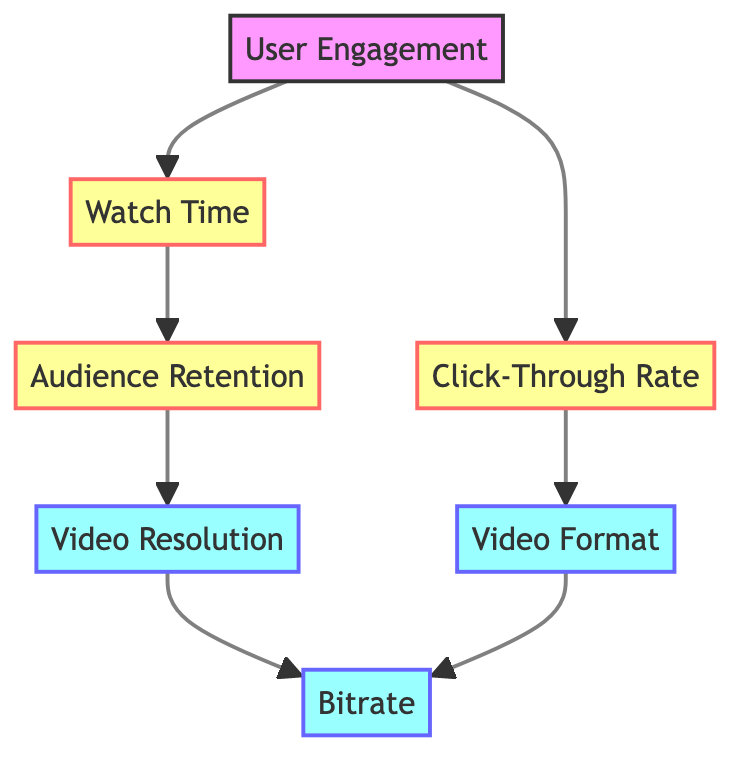What is the total number of nodes in the diagram? There are seven distinct nodes presented in the diagram: User Engagement, Watch Time, Click-Through Rate, Audience Retention, Video Resolution, Bitrate, and Video Format.
Answer: 7 What does the edge from User Engagement to Watch Time represent? This edge represents the direct influence or relationship between User Engagement and Watch Time, indicating that higher user engagement typically leads to increased watch time of videos.
Answer: Influence Which node is influenced by Audience Retention? Audience Retention influences Video Resolution, as indicated by the directed edge in the diagram that points from Audience Retention to Video Resolution.
Answer: Video Resolution What are the two nodes that directly connect to Bitrate? The two nodes that connect directly to Bitrate are Video Resolution and Video Format, as shown by the edges pointing to Bitrate from these nodes.
Answer: Video Resolution, Video Format How many edges are there in the diagram? The diagram contains six edges, representing the relationships between the nodes that illustrate how they influence one another.
Answer: 6 Which metric is influenced by both User Engagement and Watch Time? The metric influenced by both User Engagement and Watch Time is Audience Retention, as it is connected by directed edges from both metrics.
Answer: Audience Retention What is the relationship between Click-Through Rate and Video Format? Click-Through Rate directly influences Video Format, as shown by the arrow pointing from Click-Through Rate to Video Format, reflecting that a higher Click-Through Rate may lead to better decisions on video format.
Answer: Direct influence Which node does Audience Retention impact indirectly through the other nodes? Audience Retention impacts Bitrate indirectly through Video Resolution, as it connects to Video Resolution, which in turn connects to Bitrate, creating an indirect relationship.
Answer: Bitrate What type of video encoding choices does the diagram suggest might be affected by user engagement metrics? The diagram indicates that both Video Resolution and Video Format can be influenced by user engagement metrics, which include Watch Time, Click-Through Rate, and Audience Retention.
Answer: Video Resolution, Video Format 